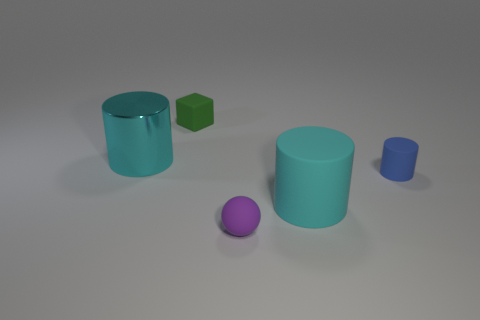There is a rubber cylinder that is the same color as the shiny thing; what size is it?
Provide a succinct answer. Large. Is there anything else that has the same size as the blue cylinder?
Your response must be concise. Yes. Does the purple sphere have the same material as the green block?
Make the answer very short. Yes. How many things are either big things that are on the right side of the metal cylinder or small rubber objects left of the cyan rubber object?
Provide a short and direct response. 3. Are there any shiny cylinders that have the same size as the purple matte object?
Ensure brevity in your answer.  No. There is a large matte thing that is the same shape as the small blue rubber thing; what is its color?
Your answer should be very brief. Cyan. Is there a green object that is on the right side of the large cyan thing right of the cube?
Your answer should be very brief. No. Does the blue thing that is behind the purple rubber ball have the same shape as the large shiny thing?
Provide a short and direct response. Yes. What shape is the purple thing?
Make the answer very short. Sphere. What number of tiny blue things are made of the same material as the cube?
Provide a succinct answer. 1. 